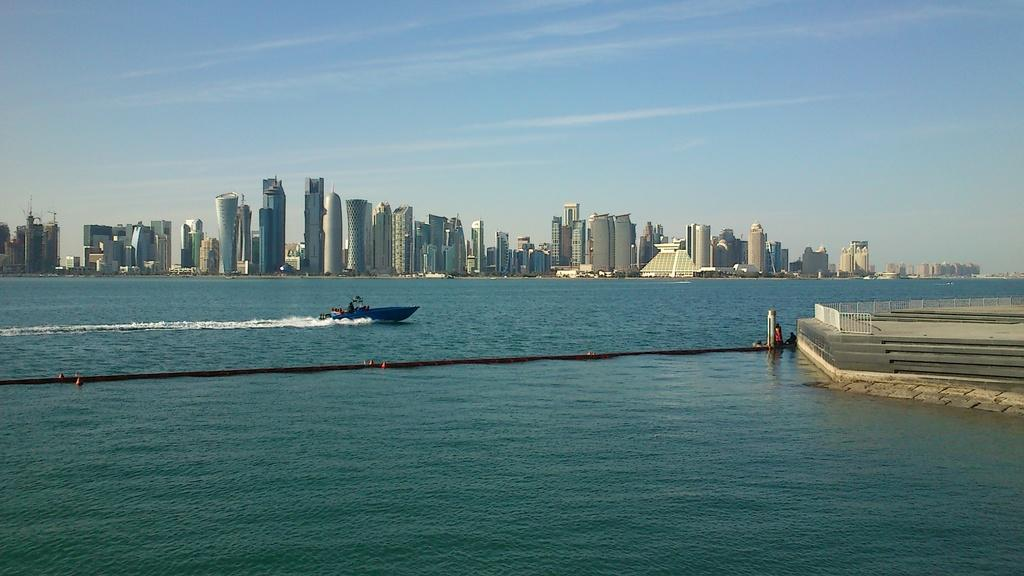What is the main subject of the image? The main subject of the image is a boat. What is the boat doing in the image? The boat is sailing on the water. What can be seen on the right side of the image? There is a pavement on the right side of the image. What is visible in the background of the image? There are tall towers and buildings in the background of the image. How many pears are being transported by the trucks in the image? There are no trucks or pears present in the image; it features a boat sailing on the water. 